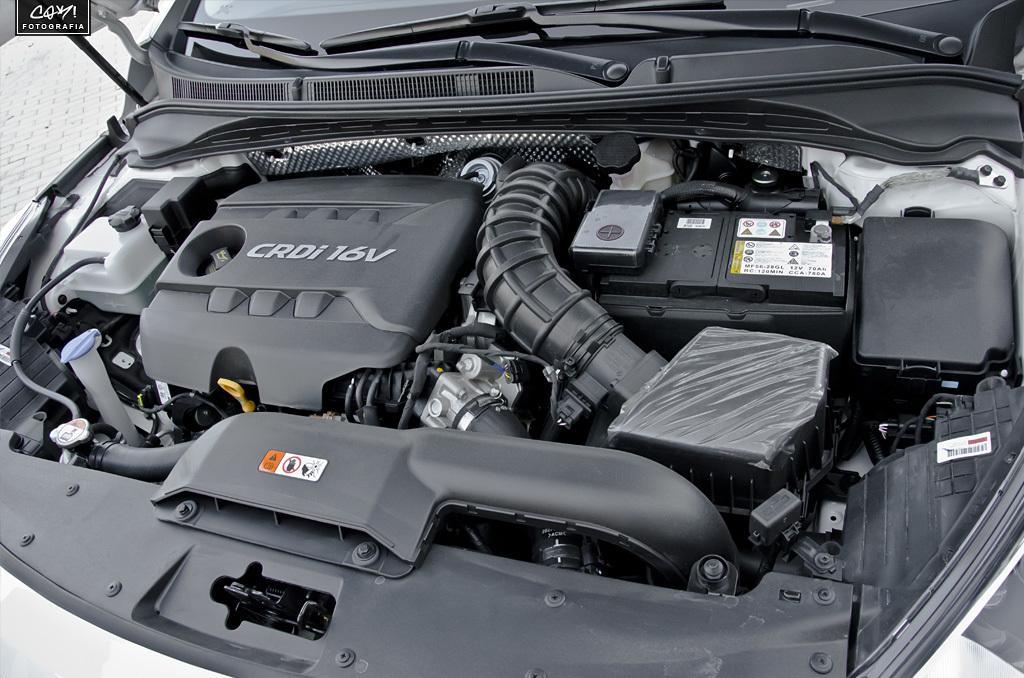How would you summarize this image in a sentence or two? In the picture we can see engine part of a car. 